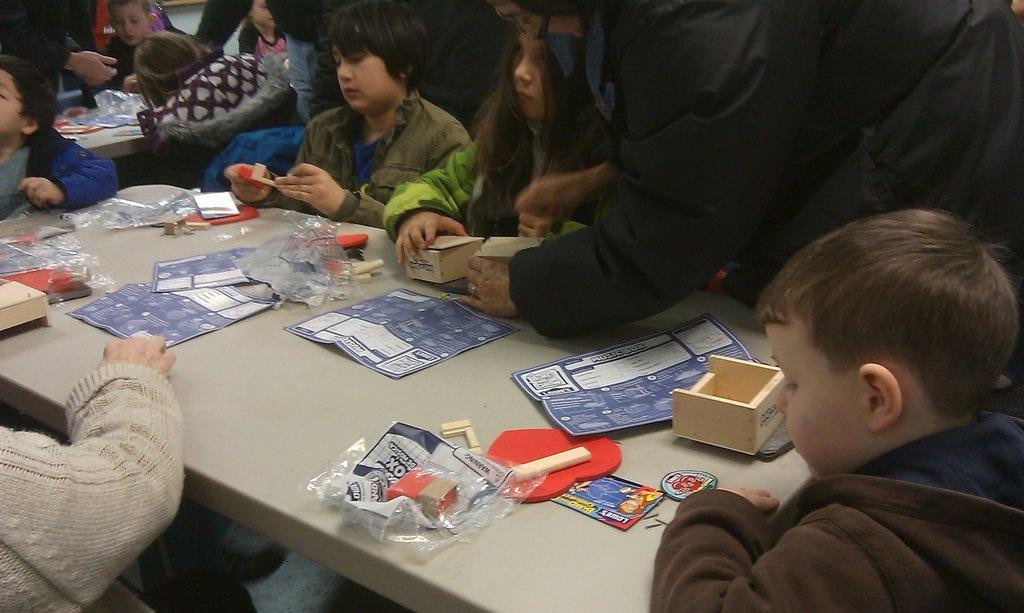What are the people in the image doing? The people in the image are sitting on chairs. What is in front of the chairs? There is a table in front of the chairs. What can be seen on the table? Papers are present on the table, along with other objects. What type of root can be seen growing from the person's head in the image? There is no root growing from anyone's head in the image; it only shows people sitting on chairs with a table in front of them. 